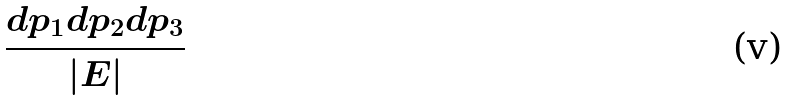<formula> <loc_0><loc_0><loc_500><loc_500>\frac { d p _ { 1 } d p _ { 2 } d p _ { 3 } } { | E | }</formula> 